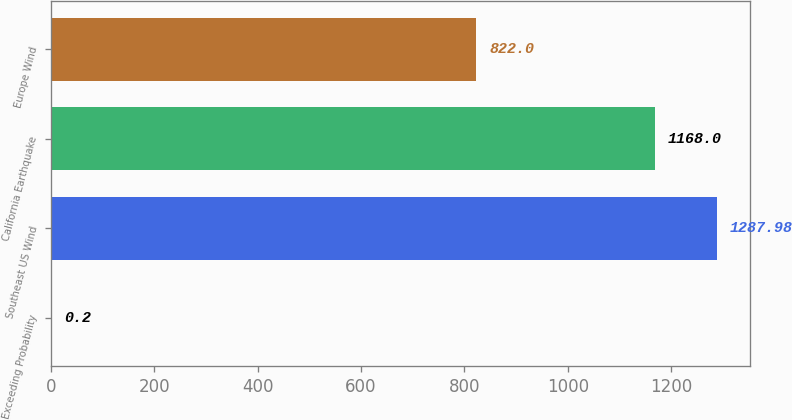Convert chart. <chart><loc_0><loc_0><loc_500><loc_500><bar_chart><fcel>Exceeding Probability<fcel>Southeast US Wind<fcel>California Earthquake<fcel>Europe Wind<nl><fcel>0.2<fcel>1287.98<fcel>1168<fcel>822<nl></chart> 